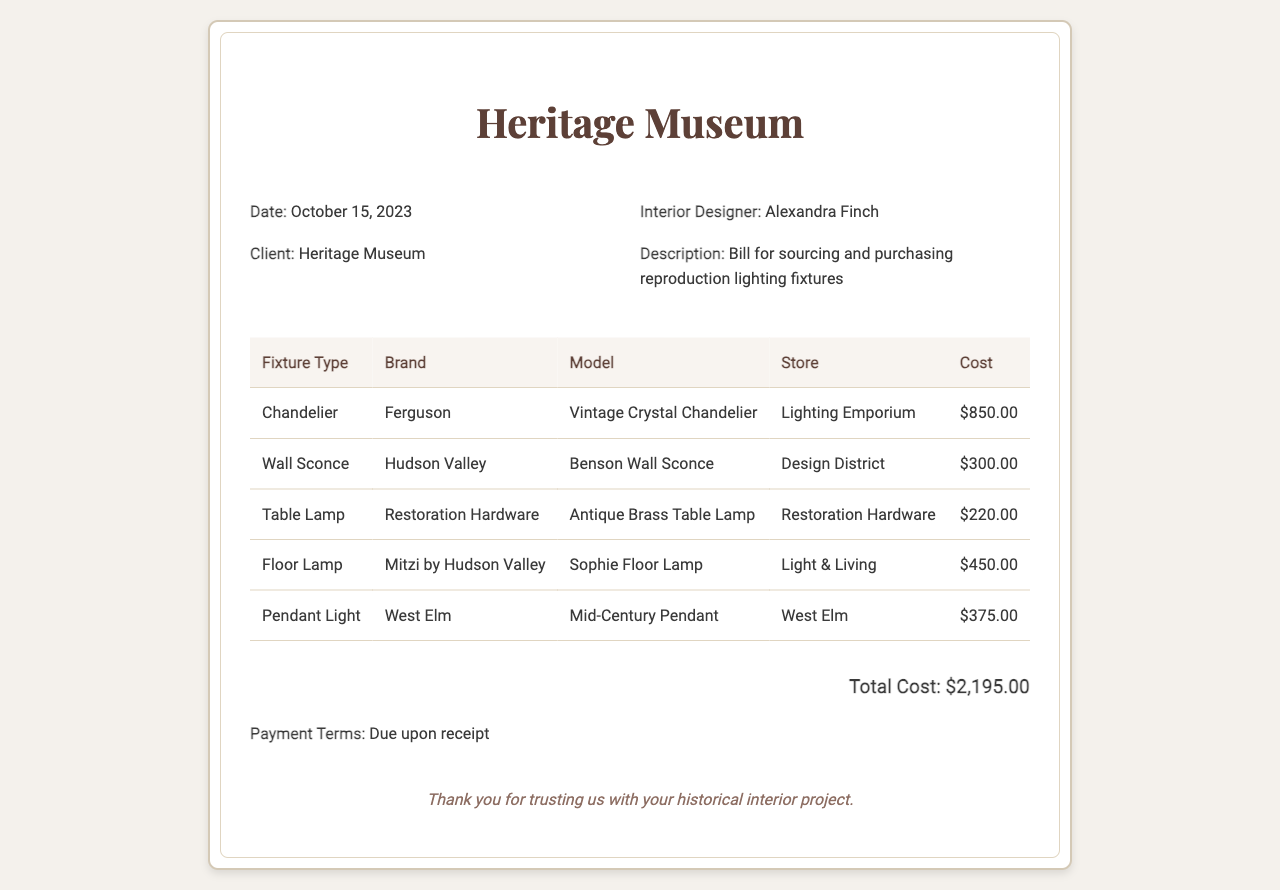What is the date of the receipt? The date is mentioned at the top of the receipt as October 15, 2023.
Answer: October 15, 2023 Who is the interior designer? The name of the interior designer is provided in the header section as Alexandra Finch.
Answer: Alexandra Finch What type of fixture is the Vintage Crystal Chandelier? The document lists it under the Fixture Type column as Chandelier.
Answer: Chandelier What is the total cost for the lighting fixtures? The total cost is clearly stated at the bottom of the receipt as $2,195.00.
Answer: $2,195.00 Which store sold the Benson Wall Sconce? The Store column indicates that it was sold at Design District.
Answer: Design District How many different lighting fixture types are listed? The document lists five distinct fixture types in the table.
Answer: Five What is the brand of the Antique Brass Table Lamp? The table specifies that the brand is Restoration Hardware.
Answer: Restoration Hardware Which fixture type has the highest cost? The Chandelier is mentioned in the table with the highest cost of $850.00.
Answer: Chandelier What are the payment terms? The document states that the payment terms are due upon receipt.
Answer: Due upon receipt 